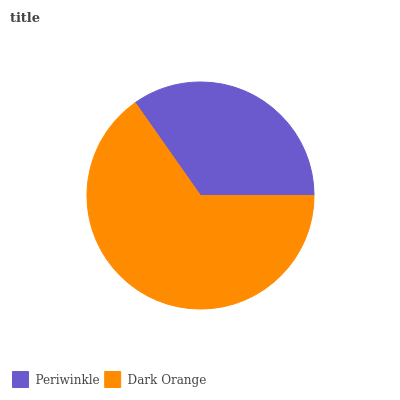Is Periwinkle the minimum?
Answer yes or no. Yes. Is Dark Orange the maximum?
Answer yes or no. Yes. Is Dark Orange the minimum?
Answer yes or no. No. Is Dark Orange greater than Periwinkle?
Answer yes or no. Yes. Is Periwinkle less than Dark Orange?
Answer yes or no. Yes. Is Periwinkle greater than Dark Orange?
Answer yes or no. No. Is Dark Orange less than Periwinkle?
Answer yes or no. No. Is Dark Orange the high median?
Answer yes or no. Yes. Is Periwinkle the low median?
Answer yes or no. Yes. Is Periwinkle the high median?
Answer yes or no. No. Is Dark Orange the low median?
Answer yes or no. No. 